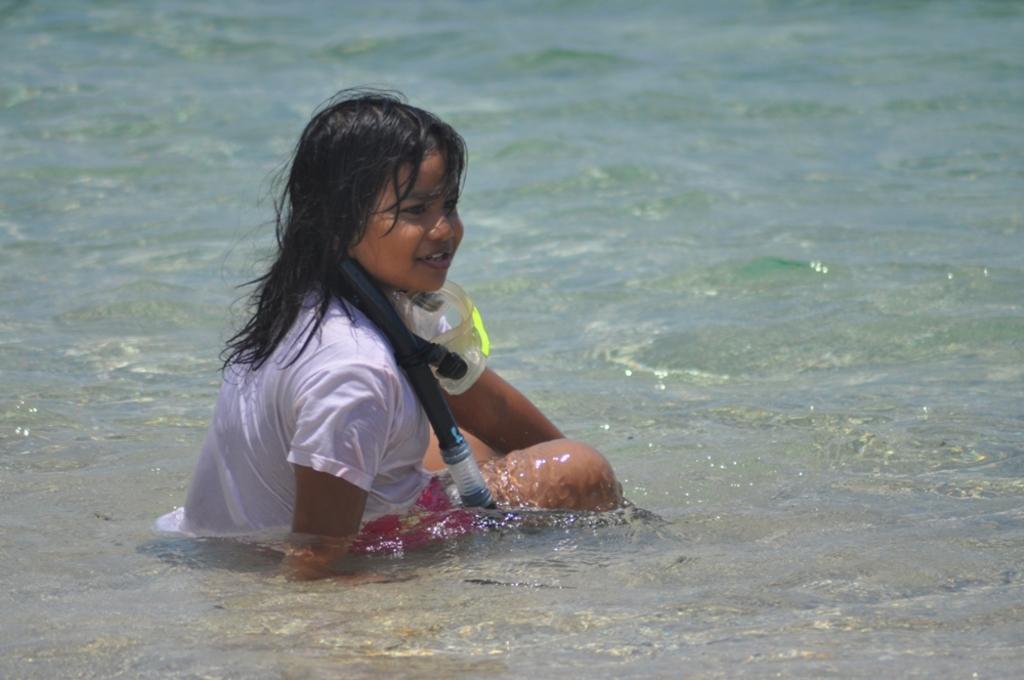Could you give a brief overview of what you see in this image? In the center of the image, we can see a kid wearing an oxygen mask. At the bottom, there is water. 